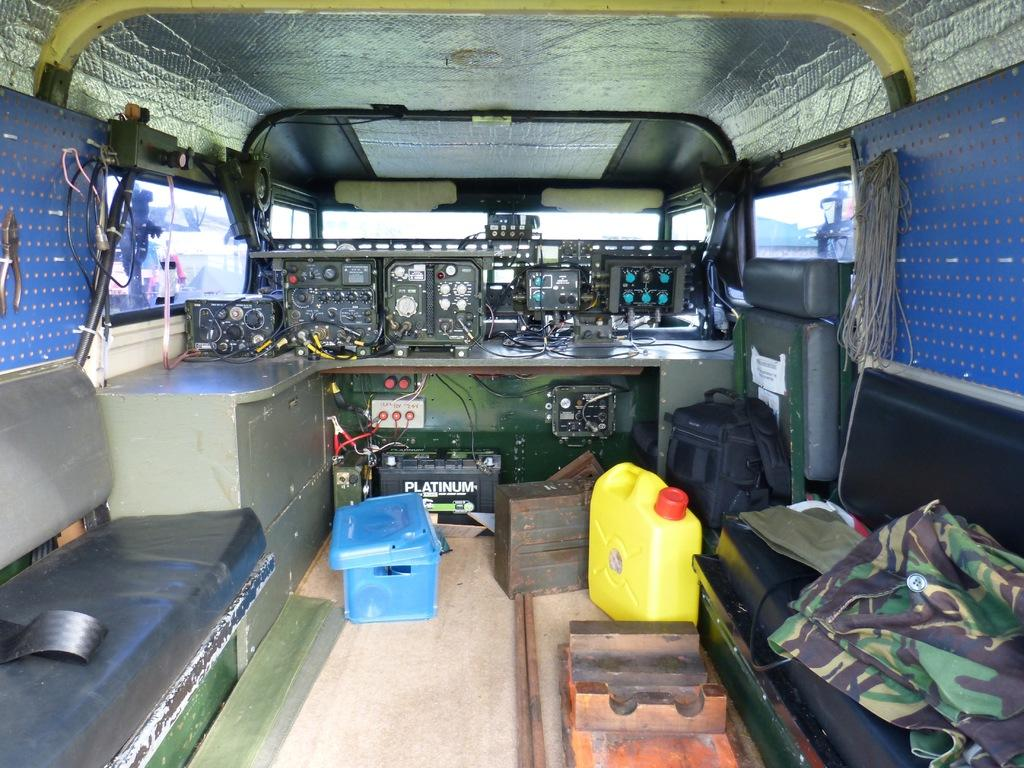What is placed on the seat in the right corner of the image? There are clothes placed on a seat in the right corner of the image. What can be seen in the background of the image? There are electronic objects in the background of the image. What type of dirt can be seen on the clothes in the image? There is no dirt visible on the clothes in the image. What type of land is depicted in the image? The image does not depict any land; it primarily features clothes and electronic objects. 